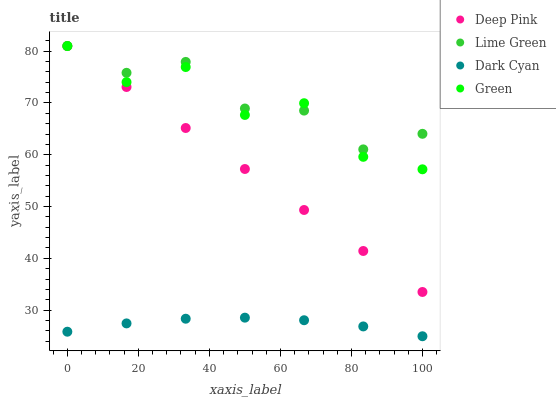Does Dark Cyan have the minimum area under the curve?
Answer yes or no. Yes. Does Lime Green have the maximum area under the curve?
Answer yes or no. Yes. Does Green have the minimum area under the curve?
Answer yes or no. No. Does Green have the maximum area under the curve?
Answer yes or no. No. Is Deep Pink the smoothest?
Answer yes or no. Yes. Is Green the roughest?
Answer yes or no. Yes. Is Green the smoothest?
Answer yes or no. No. Is Deep Pink the roughest?
Answer yes or no. No. Does Dark Cyan have the lowest value?
Answer yes or no. Yes. Does Green have the lowest value?
Answer yes or no. No. Does Lime Green have the highest value?
Answer yes or no. Yes. Is Dark Cyan less than Deep Pink?
Answer yes or no. Yes. Is Lime Green greater than Dark Cyan?
Answer yes or no. Yes. Does Lime Green intersect Green?
Answer yes or no. Yes. Is Lime Green less than Green?
Answer yes or no. No. Is Lime Green greater than Green?
Answer yes or no. No. Does Dark Cyan intersect Deep Pink?
Answer yes or no. No. 